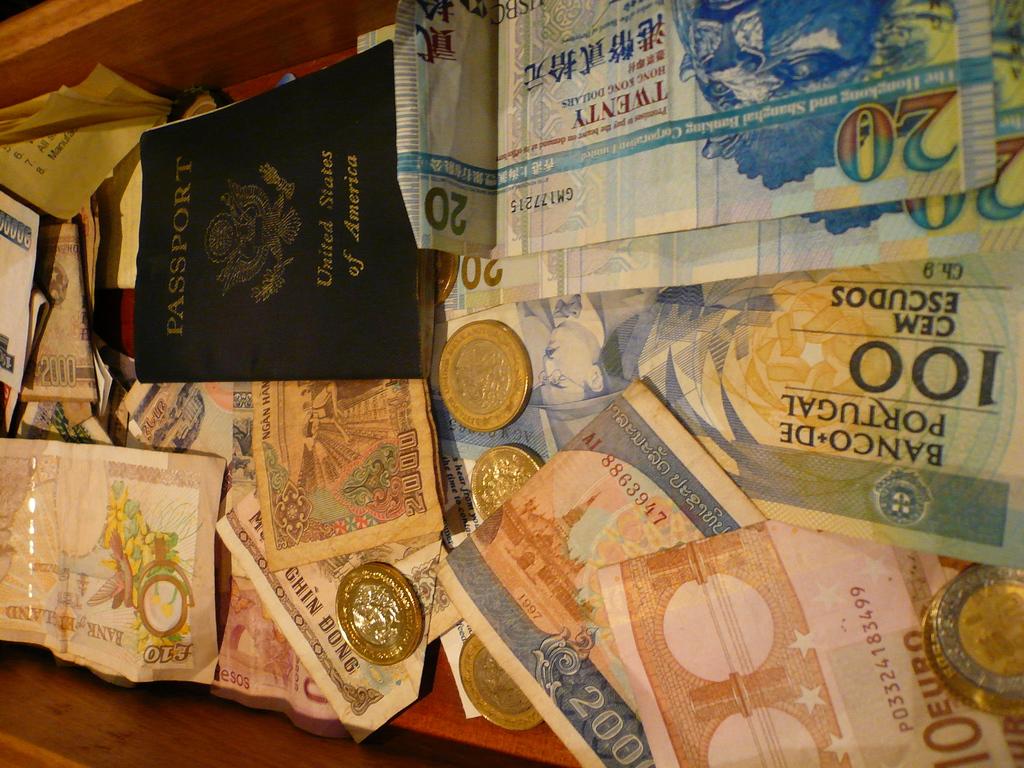What united states object here allows travel outside the us?
Your response must be concise. Passport. 